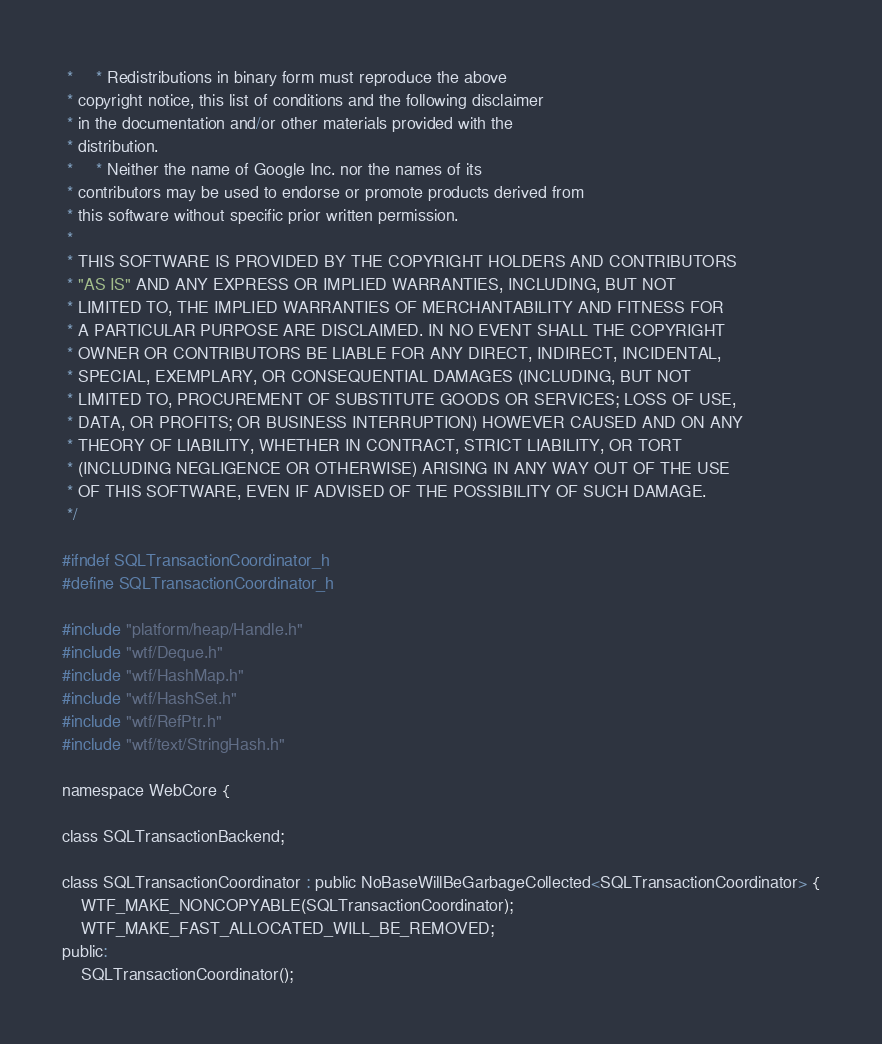<code> <loc_0><loc_0><loc_500><loc_500><_C_> *     * Redistributions in binary form must reproduce the above
 * copyright notice, this list of conditions and the following disclaimer
 * in the documentation and/or other materials provided with the
 * distribution.
 *     * Neither the name of Google Inc. nor the names of its
 * contributors may be used to endorse or promote products derived from
 * this software without specific prior written permission.
 *
 * THIS SOFTWARE IS PROVIDED BY THE COPYRIGHT HOLDERS AND CONTRIBUTORS
 * "AS IS" AND ANY EXPRESS OR IMPLIED WARRANTIES, INCLUDING, BUT NOT
 * LIMITED TO, THE IMPLIED WARRANTIES OF MERCHANTABILITY AND FITNESS FOR
 * A PARTICULAR PURPOSE ARE DISCLAIMED. IN NO EVENT SHALL THE COPYRIGHT
 * OWNER OR CONTRIBUTORS BE LIABLE FOR ANY DIRECT, INDIRECT, INCIDENTAL,
 * SPECIAL, EXEMPLARY, OR CONSEQUENTIAL DAMAGES (INCLUDING, BUT NOT
 * LIMITED TO, PROCUREMENT OF SUBSTITUTE GOODS OR SERVICES; LOSS OF USE,
 * DATA, OR PROFITS; OR BUSINESS INTERRUPTION) HOWEVER CAUSED AND ON ANY
 * THEORY OF LIABILITY, WHETHER IN CONTRACT, STRICT LIABILITY, OR TORT
 * (INCLUDING NEGLIGENCE OR OTHERWISE) ARISING IN ANY WAY OUT OF THE USE
 * OF THIS SOFTWARE, EVEN IF ADVISED OF THE POSSIBILITY OF SUCH DAMAGE.
 */

#ifndef SQLTransactionCoordinator_h
#define SQLTransactionCoordinator_h

#include "platform/heap/Handle.h"
#include "wtf/Deque.h"
#include "wtf/HashMap.h"
#include "wtf/HashSet.h"
#include "wtf/RefPtr.h"
#include "wtf/text/StringHash.h"

namespace WebCore {

class SQLTransactionBackend;

class SQLTransactionCoordinator : public NoBaseWillBeGarbageCollected<SQLTransactionCoordinator> {
    WTF_MAKE_NONCOPYABLE(SQLTransactionCoordinator);
    WTF_MAKE_FAST_ALLOCATED_WILL_BE_REMOVED;
public:
    SQLTransactionCoordinator();</code> 